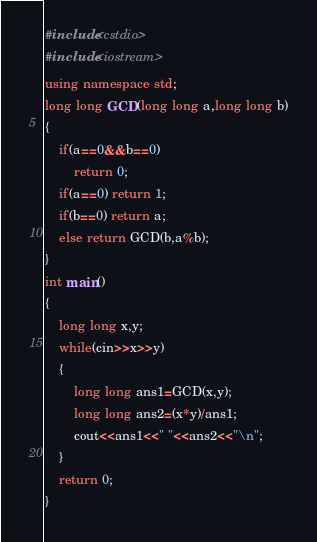<code> <loc_0><loc_0><loc_500><loc_500><_C++_>#include<cstdio>
#include<iostream>
using namespace std;
long long GCD(long long a,long long b)
{
    if(a==0&&b==0)
        return 0;
    if(a==0) return 1;
    if(b==0) return a;
    else return GCD(b,a%b);
}
int main()
{
    long long x,y;
    while(cin>>x>>y)
    {
        long long ans1=GCD(x,y);
        long long ans2=(x*y)/ans1;
        cout<<ans1<<" "<<ans2<<"\n";
    }
	return 0;
}</code> 